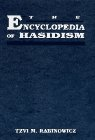What is the title of this book?
Answer the question using a single word or phrase. The Encyclopedia of Hasidism What type of book is this? Religion & Spirituality Is this a religious book? Yes Is this a games related book? No 